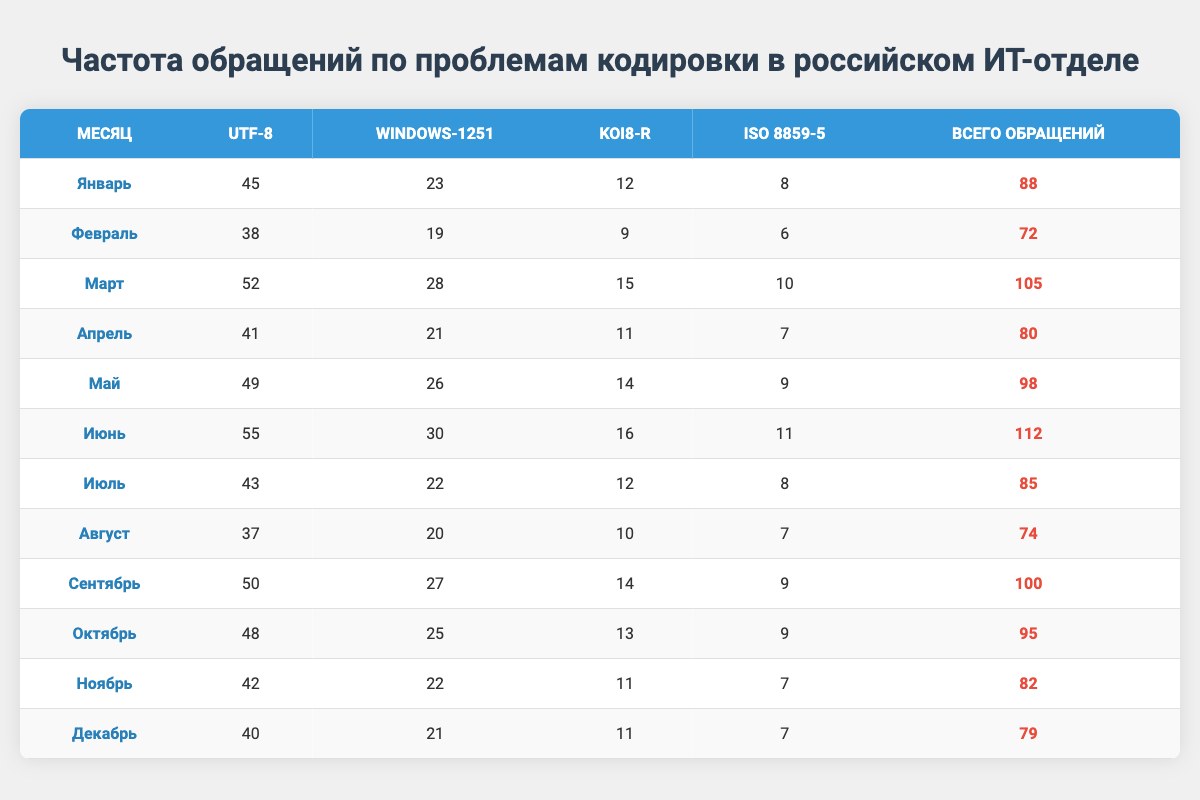What month had the highest number of UTF-8 issues? Looking through the UTF-8 Issues column, March has the highest value with 52.
Answer: March What is the total number of Windows-1251 issues for the first half of the year? Summing the Windows-1251 Issues for January to June: 23 + 19 + 28 + 21 + 26 + 30 =  7. Adding these gives us a total of 147.
Answer: 147 Was there any month with fewer than 10 ISO 8859-5 issues? Yes, both February and April have 6 and 7 ISO 8859-5 issues, respectively, which are fewer than 10.
Answer: Yes What was the average number of KOI8-R issues per month? Adding up all the KOI8-R issues: 12 + 9 + 15 + 11 + 14 + 16 + 12 + 10 + 14 + 13 + 11 + 11 =  6. Dividing by 12 gives an average of approximately 12.5.
Answer: 12.5 Which month had the lowest total number of tickets? By checking the Total Tickets column, February has the lowest total with 72 tickets.
Answer: February How many more UTF-8 issues were there in June compared to January? In June, there were 55 UTF-8 issues, and in January, there were 45. The difference is 55 - 45 = 10.
Answer: 10 What was the percentage of total tickets that were related to Windows-1251 issues in May? In May, there were 26 Windows-1251 issues out of 98 total tickets. The percentage is (26/98) * 100 ≈ 26.53%.
Answer: 26.53% During which month was the total number of tickets closest to 80? Examining the Total Tickets column, April has 80 tickets, which is exactly the same.
Answer: April How many months had more than 90 total tickets? Looking at the Total Tickets column, June (112), March (105), May (98), September (100), October (95) are the months, so the count is 5 months.
Answer: 5 